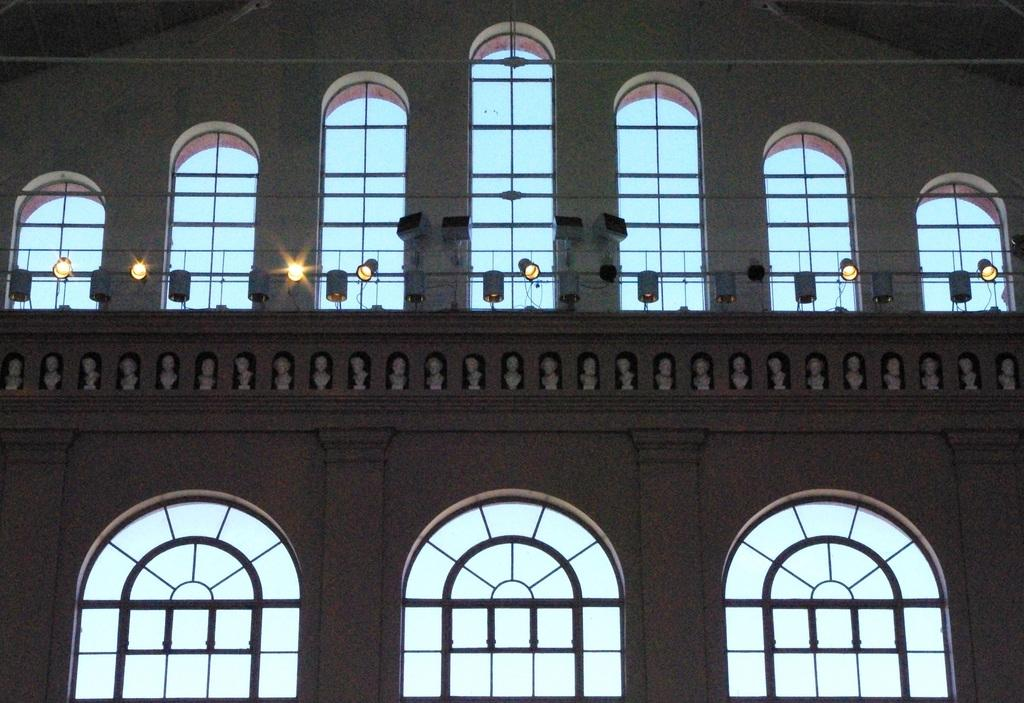What type of structural elements can be seen in the image? In the image, there are rods, pillars, and arches. What type of lighting is present in the image? There are dome lights in the image. What can be inferred about the location of the image? The image is an inside view of a building. What type of leaf is falling from the ceiling in the image? There are no leaves present in the image; it is an inside view of a building with structural elements and dome lights. 